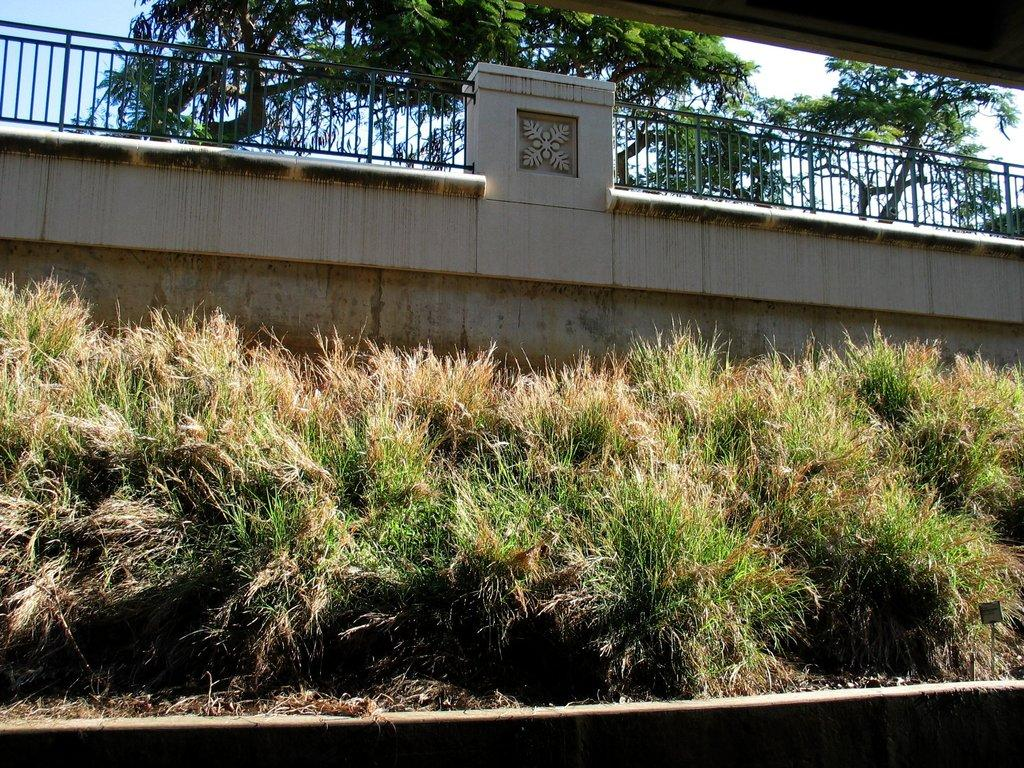What type of vegetation is near the wall in the image? There are grass plants near the wall in the image. What structure is near the grass plants and wall? There is a railing near the wall in the image. What can be seen behind the railing in the image? Trees are visible behind the railing in the image. What part of the natural environment is visible in the image? The sky is partially visible in the image. Where is the airport located in the image? There is no airport present in the image. Can you spot any ladybugs on the grass plants in the image? There are no ladybugs visible in the image; only grass plants, a railing, trees, and the sky can be seen. 